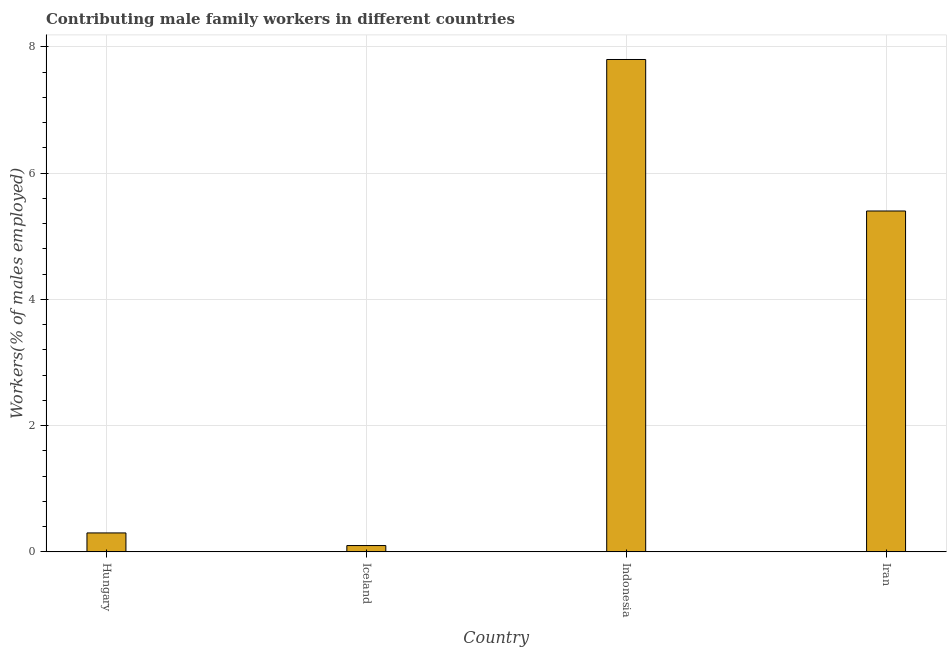Does the graph contain any zero values?
Your response must be concise. No. Does the graph contain grids?
Your answer should be very brief. Yes. What is the title of the graph?
Offer a terse response. Contributing male family workers in different countries. What is the label or title of the Y-axis?
Keep it short and to the point. Workers(% of males employed). What is the contributing male family workers in Iran?
Your answer should be compact. 5.4. Across all countries, what is the maximum contributing male family workers?
Your response must be concise. 7.8. Across all countries, what is the minimum contributing male family workers?
Provide a succinct answer. 0.1. In which country was the contributing male family workers maximum?
Your answer should be very brief. Indonesia. What is the sum of the contributing male family workers?
Offer a very short reply. 13.6. What is the difference between the contributing male family workers in Hungary and Iceland?
Make the answer very short. 0.2. What is the average contributing male family workers per country?
Keep it short and to the point. 3.4. What is the median contributing male family workers?
Provide a short and direct response. 2.85. In how many countries, is the contributing male family workers greater than 2 %?
Ensure brevity in your answer.  2. What is the ratio of the contributing male family workers in Iceland to that in Indonesia?
Your response must be concise. 0.01. What is the difference between the highest and the lowest contributing male family workers?
Your answer should be compact. 7.7. In how many countries, is the contributing male family workers greater than the average contributing male family workers taken over all countries?
Your answer should be very brief. 2. Are all the bars in the graph horizontal?
Give a very brief answer. No. How many countries are there in the graph?
Provide a succinct answer. 4. What is the Workers(% of males employed) of Hungary?
Ensure brevity in your answer.  0.3. What is the Workers(% of males employed) in Iceland?
Make the answer very short. 0.1. What is the Workers(% of males employed) in Indonesia?
Your response must be concise. 7.8. What is the Workers(% of males employed) of Iran?
Make the answer very short. 5.4. What is the difference between the Workers(% of males employed) in Iceland and Indonesia?
Provide a succinct answer. -7.7. What is the ratio of the Workers(% of males employed) in Hungary to that in Indonesia?
Give a very brief answer. 0.04. What is the ratio of the Workers(% of males employed) in Hungary to that in Iran?
Offer a terse response. 0.06. What is the ratio of the Workers(% of males employed) in Iceland to that in Indonesia?
Offer a terse response. 0.01. What is the ratio of the Workers(% of males employed) in Iceland to that in Iran?
Your response must be concise. 0.02. What is the ratio of the Workers(% of males employed) in Indonesia to that in Iran?
Ensure brevity in your answer.  1.44. 